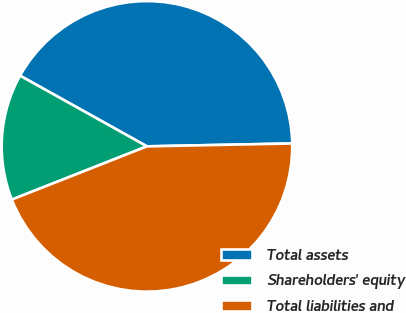<chart> <loc_0><loc_0><loc_500><loc_500><pie_chart><fcel>Total assets<fcel>Shareholders' equity<fcel>Total liabilities and<nl><fcel>41.59%<fcel>14.06%<fcel>44.34%<nl></chart> 